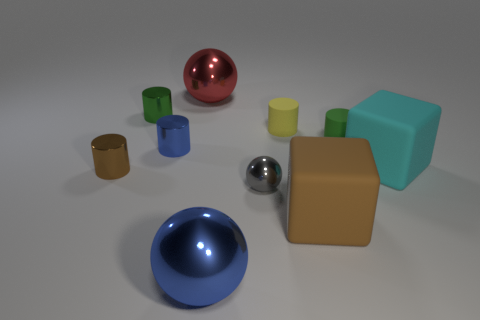How many large objects are behind the big brown object and on the right side of the red thing?
Make the answer very short. 1. Are there any other things that have the same shape as the big cyan thing?
Give a very brief answer. Yes. There is a blue thing that is behind the brown block; what is its size?
Keep it short and to the point. Small. What number of other objects are there of the same color as the tiny sphere?
Your answer should be very brief. 0. What material is the brown thing on the right side of the large metallic object that is behind the brown matte cube?
Make the answer very short. Rubber. How many other large metallic things have the same shape as the large cyan object?
Your answer should be compact. 0. The red object that is made of the same material as the tiny brown object is what size?
Offer a terse response. Large. There is a large metal object in front of the large shiny object behind the tiny gray metallic ball; are there any small green cylinders that are on the left side of it?
Offer a very short reply. Yes. There is a cylinder that is behind the yellow cylinder; is its size the same as the cyan matte object?
Provide a succinct answer. No. What number of metallic objects have the same size as the cyan matte block?
Ensure brevity in your answer.  2. 